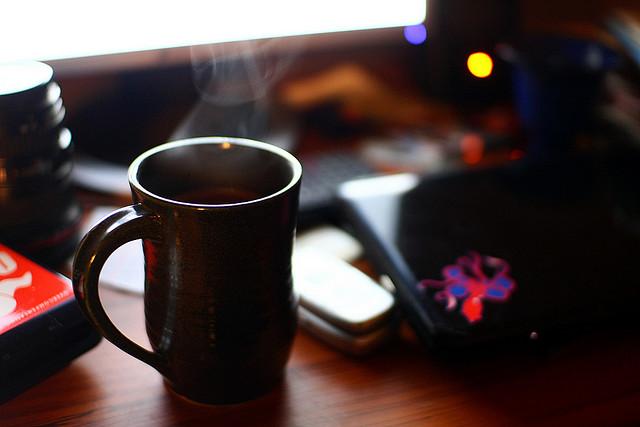Is the coffee hot?
Answer briefly. Yes. Is there a cell phone on the table?
Give a very brief answer. Yes. Where is the coffee mug?
Answer briefly. Table. 